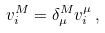<formula> <loc_0><loc_0><loc_500><loc_500>v ^ { M } _ { i } = \delta ^ { M } _ { \mu } v _ { i } ^ { \mu } \, ,</formula> 